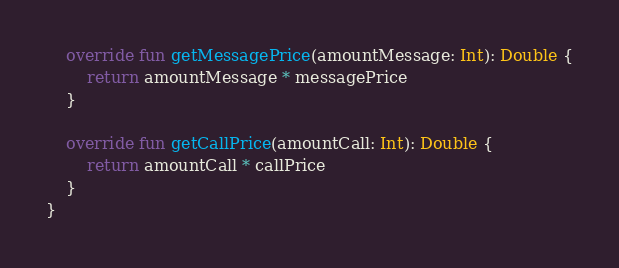Convert code to text. <code><loc_0><loc_0><loc_500><loc_500><_Kotlin_>    override fun getMessagePrice(amountMessage: Int): Double {
        return amountMessage * messagePrice
    }

    override fun getCallPrice(amountCall: Int): Double {
        return amountCall * callPrice
    }
}</code> 